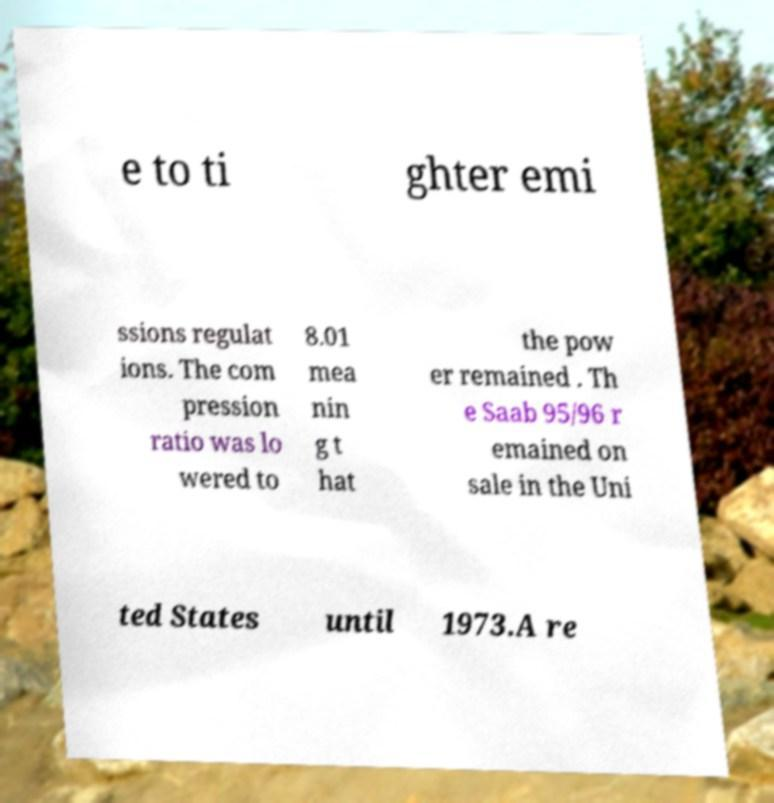Could you extract and type out the text from this image? e to ti ghter emi ssions regulat ions. The com pression ratio was lo wered to 8.01 mea nin g t hat the pow er remained . Th e Saab 95/96 r emained on sale in the Uni ted States until 1973.A re 